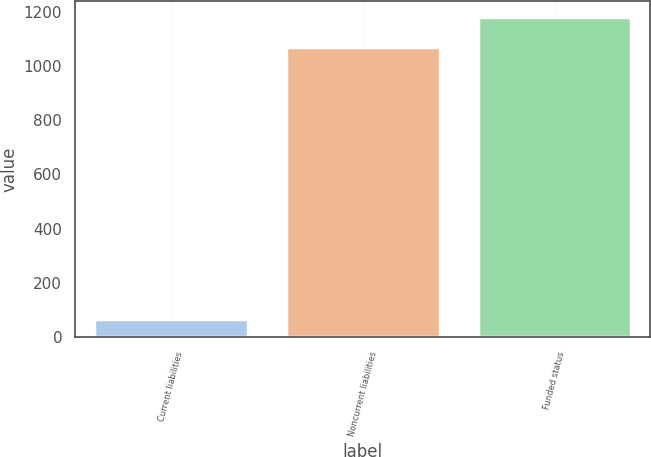Convert chart. <chart><loc_0><loc_0><loc_500><loc_500><bar_chart><fcel>Current liabilities<fcel>Noncurrent liabilities<fcel>Funded status<nl><fcel>65<fcel>1071<fcel>1178.1<nl></chart> 